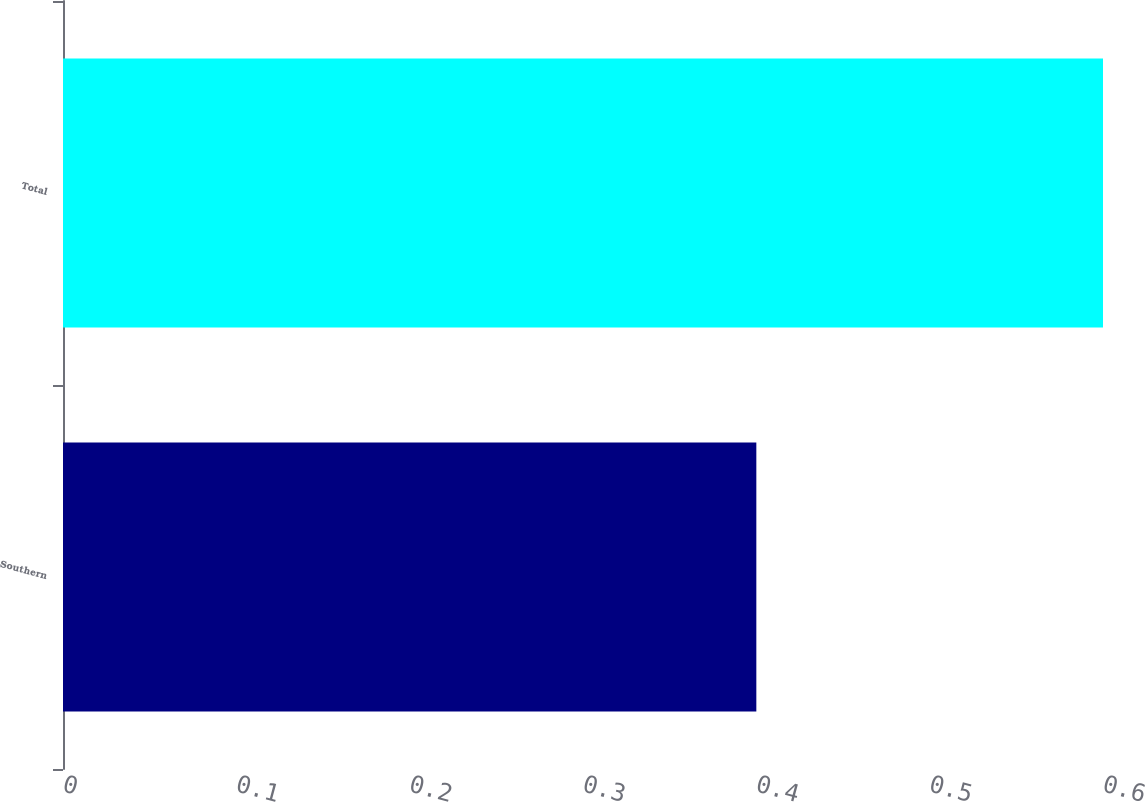Convert chart. <chart><loc_0><loc_0><loc_500><loc_500><bar_chart><fcel>Southern<fcel>Total<nl><fcel>0.4<fcel>0.6<nl></chart> 